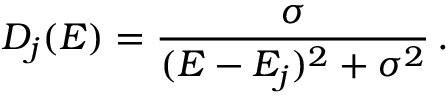<formula> <loc_0><loc_0><loc_500><loc_500>D _ { j } ( E ) = \frac { \sigma } { ( E - E _ { j } ) ^ { 2 } + \sigma ^ { 2 } } \, .</formula> 